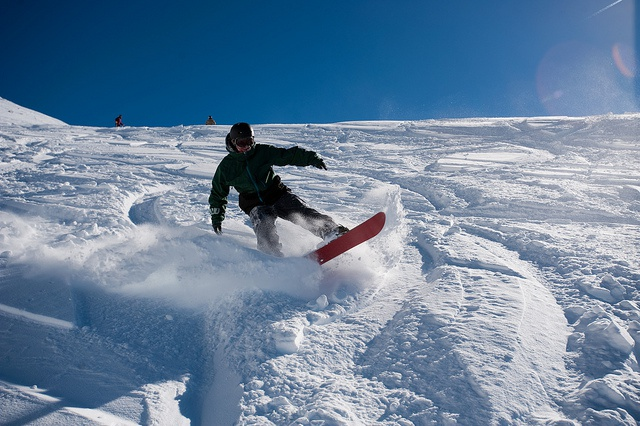Describe the objects in this image and their specific colors. I can see people in navy, black, gray, and darkgray tones, snowboard in navy, maroon, gray, darkgray, and purple tones, people in navy, black, blue, and gray tones, and people in navy, black, blue, and maroon tones in this image. 